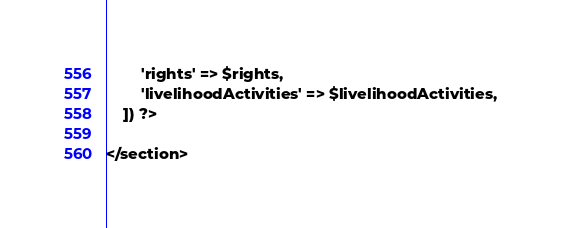<code> <loc_0><loc_0><loc_500><loc_500><_PHP_>        'rights' => $rights,
        'livelihoodActivities' => $livelihoodActivities,
    ]) ?>

</section>
</code> 